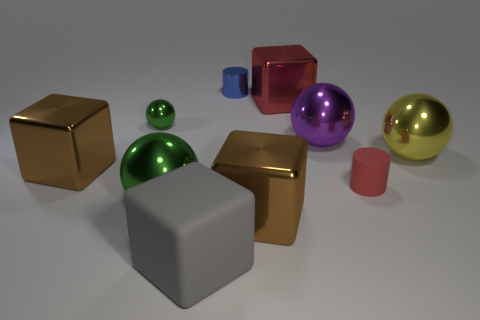Are there any other things that have the same material as the blue cylinder?
Provide a short and direct response. Yes. There is a cube that is the same color as the tiny rubber thing; what is it made of?
Ensure brevity in your answer.  Metal. What is the color of the small thing in front of the brown shiny object that is on the left side of the blue shiny cylinder?
Your response must be concise. Red. Are there any purple things made of the same material as the tiny red object?
Ensure brevity in your answer.  No. The brown thing that is in front of the cylinder to the right of the big red block is made of what material?
Provide a short and direct response. Metal. What number of other small red objects are the same shape as the red rubber object?
Give a very brief answer. 0. The gray rubber thing has what shape?
Ensure brevity in your answer.  Cube. Are there fewer big red things than small purple rubber cylinders?
Your answer should be very brief. No. Are there any other things that are the same size as the purple thing?
Keep it short and to the point. Yes. There is a red object that is the same shape as the blue metal thing; what is its material?
Your answer should be compact. Rubber. 